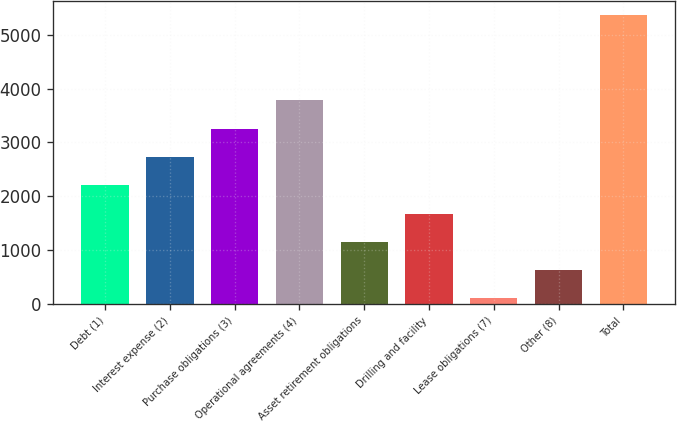Convert chart to OTSL. <chart><loc_0><loc_0><loc_500><loc_500><bar_chart><fcel>Debt (1)<fcel>Interest expense (2)<fcel>Purchase obligations (3)<fcel>Operational agreements (4)<fcel>Asset retirement obligations<fcel>Drilling and facility<fcel>Lease obligations (7)<fcel>Other (8)<fcel>Total<nl><fcel>2203.6<fcel>2729.5<fcel>3255.4<fcel>3781.3<fcel>1151.8<fcel>1677.7<fcel>100<fcel>625.9<fcel>5359<nl></chart> 